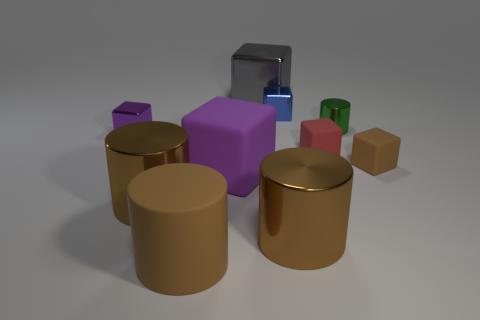The red thing that is made of the same material as the big purple thing is what size?
Provide a short and direct response. Small. What is the shape of the thing that is on the right side of the tiny metal thing to the right of the red cube?
Provide a short and direct response. Cube. How many blue things are shiny cylinders or small rubber things?
Provide a succinct answer. 0. Is there a small blue block behind the big metallic thing to the left of the large thing behind the blue shiny block?
Provide a succinct answer. Yes. The small thing that is the same color as the large matte block is what shape?
Provide a short and direct response. Cube. What number of tiny objects are either gray shiny cubes or brown balls?
Ensure brevity in your answer.  0. There is a purple object in front of the small brown matte thing; does it have the same shape as the tiny purple thing?
Your answer should be very brief. Yes. Are there fewer purple metallic blocks than big cubes?
Your answer should be compact. Yes. Are there any other things that have the same color as the rubber cylinder?
Your answer should be compact. Yes. The brown matte thing in front of the brown matte block has what shape?
Provide a short and direct response. Cylinder. 